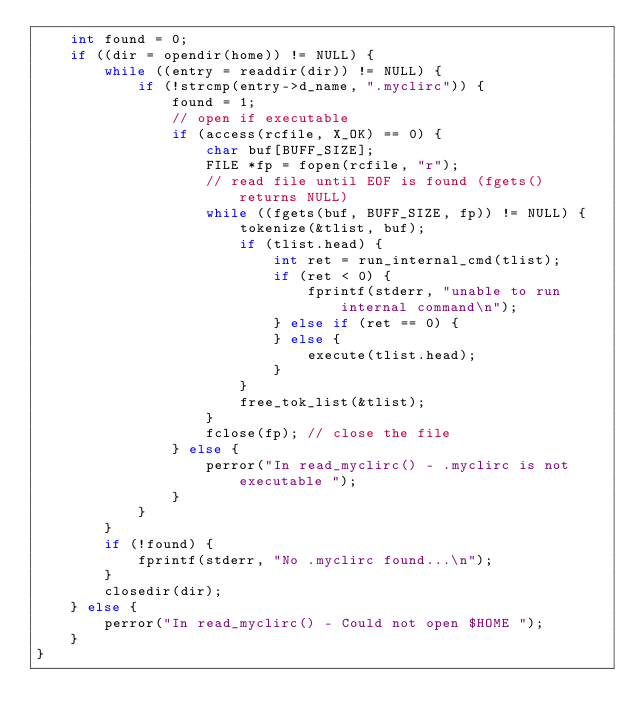<code> <loc_0><loc_0><loc_500><loc_500><_C_>    int found = 0;
    if ((dir = opendir(home)) != NULL) {
        while ((entry = readdir(dir)) != NULL) {
            if (!strcmp(entry->d_name, ".myclirc")) {
                found = 1;
                // open if executable
                if (access(rcfile, X_OK) == 0) {
                    char buf[BUFF_SIZE];
                    FILE *fp = fopen(rcfile, "r");
                    // read file until EOF is found (fgets() returns NULL)
                    while ((fgets(buf, BUFF_SIZE, fp)) != NULL) {
                        tokenize(&tlist, buf);
                        if (tlist.head) {
                            int ret = run_internal_cmd(tlist);
                            if (ret < 0) {
                                fprintf(stderr, "unable to run internal command\n");
                            } else if (ret == 0) {
                            } else {
                                execute(tlist.head);
                            }
                        }
                        free_tok_list(&tlist);
                    }
                    fclose(fp); // close the file
                } else {
                    perror("In read_myclirc() - .myclirc is not executable ");
                }
            }
        }
        if (!found) {
            fprintf(stderr, "No .myclirc found...\n");
        }
        closedir(dir);
    } else {
        perror("In read_myclirc() - Could not open $HOME ");
    }
}
</code> 